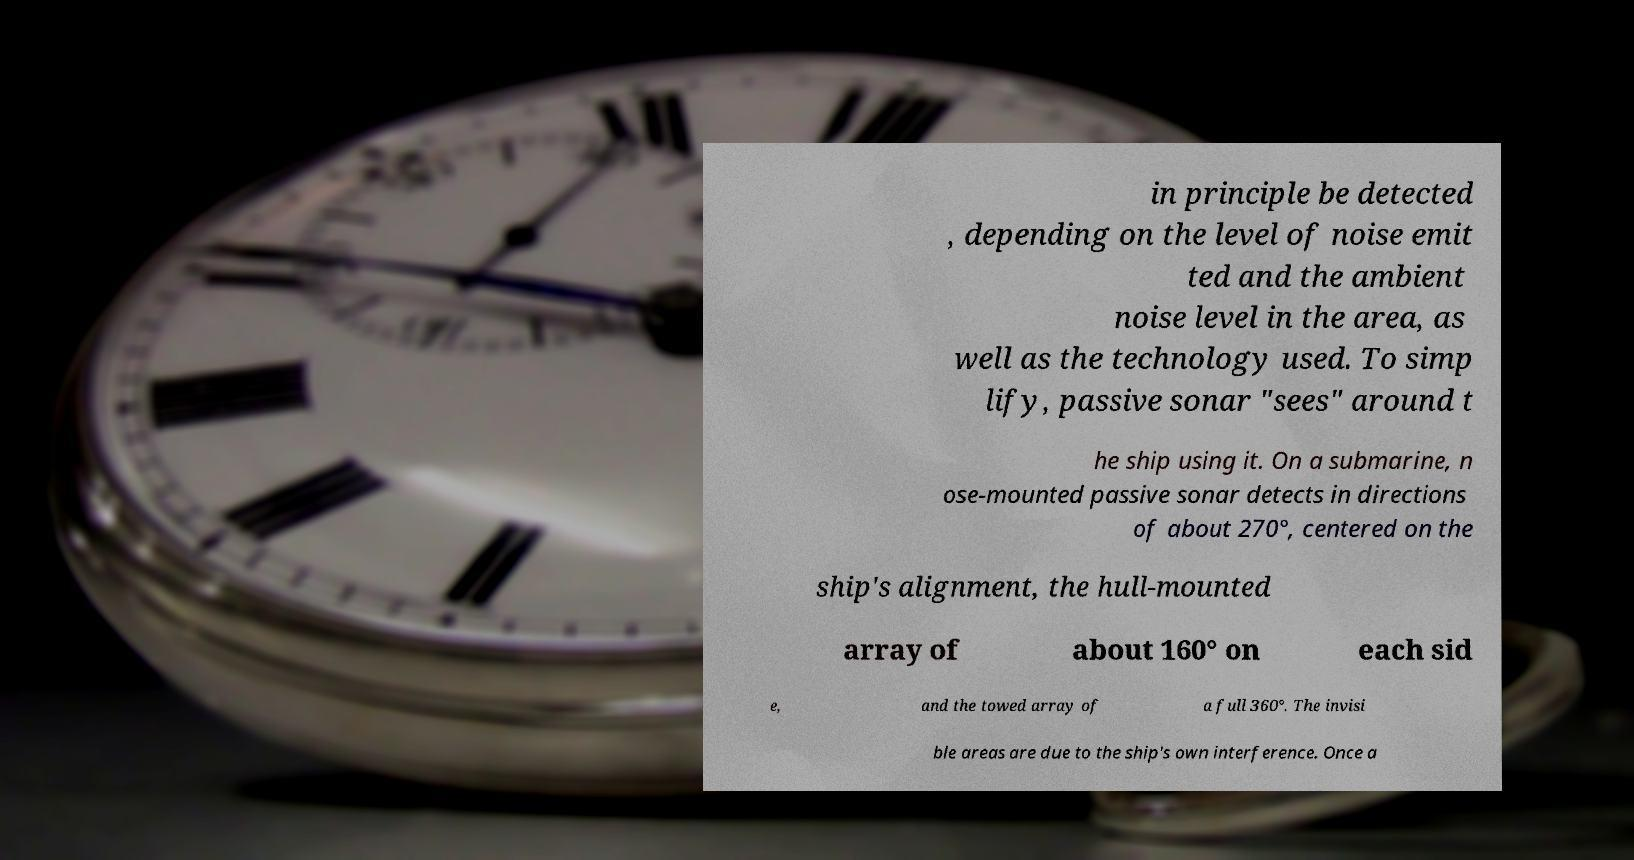Please read and relay the text visible in this image. What does it say? in principle be detected , depending on the level of noise emit ted and the ambient noise level in the area, as well as the technology used. To simp lify, passive sonar "sees" around t he ship using it. On a submarine, n ose-mounted passive sonar detects in directions of about 270°, centered on the ship's alignment, the hull-mounted array of about 160° on each sid e, and the towed array of a full 360°. The invisi ble areas are due to the ship's own interference. Once a 